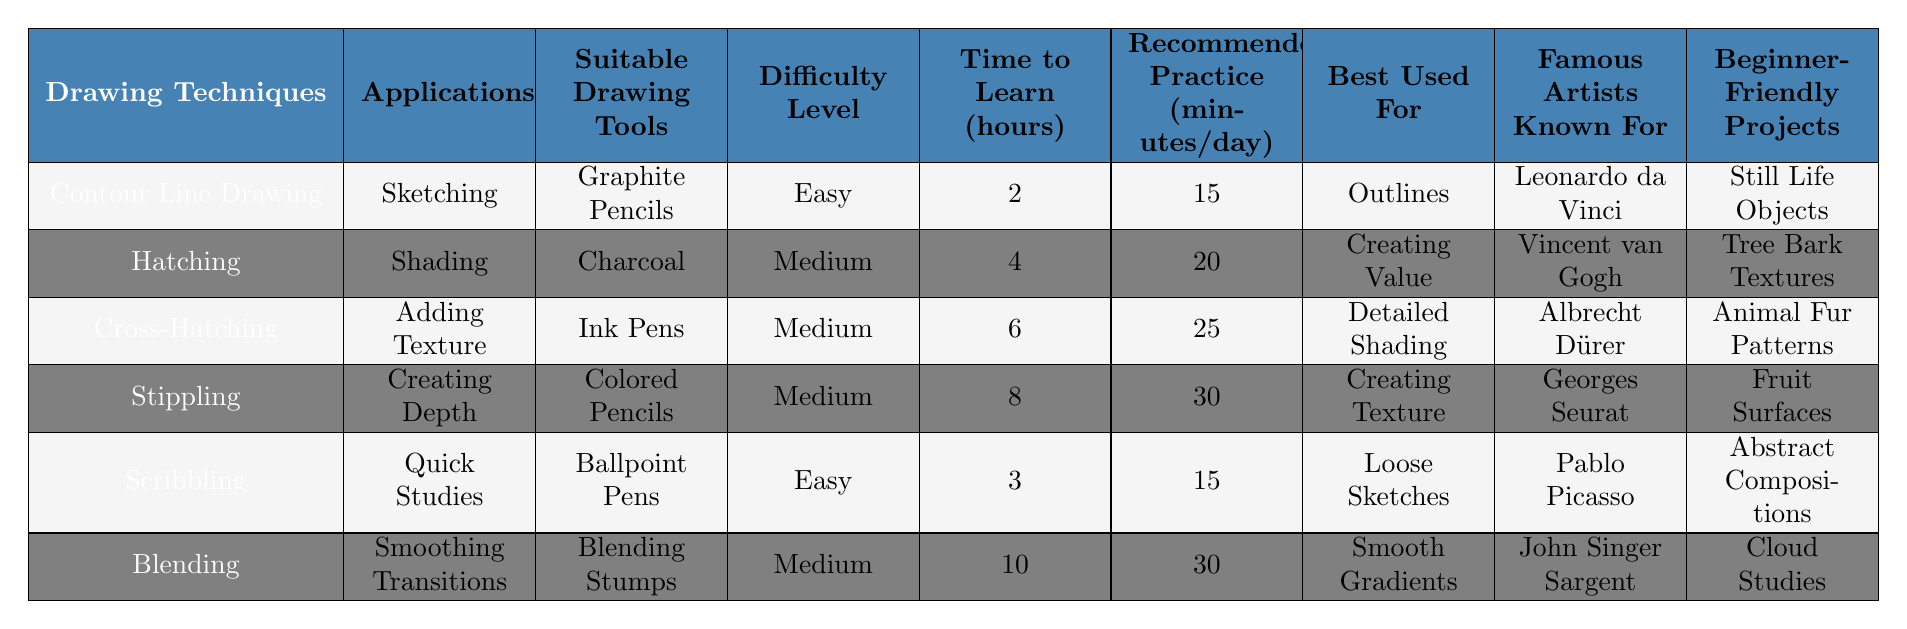What is the most difficult drawing technique to learn? The drawing technique with the highest difficulty level listed in the table is "Blending," which is categorized as "Medium," but it has the longest time to learn at 10 hours, indicating it might be more challenging in practice.
Answer: Blending Which drawing technique is best for adding texture? According to the table, "Cross-Hatching" is specifically listed as being used for "Adding Texture."
Answer: Cross-Hatching How many hours does it take to learn "Scribbling"? The table indicates that "Scribbling" takes 3 hours to learn.
Answer: 3 hours Are all drawing techniques suitable for beginners? No, not all techniques are suitable for beginners; "Hatching," "Cross-Hatching," "Stippling," and "Blending" are categorized as "Medium" in difficulty.
Answer: No What is the average time to learn all the drawing techniques? To find the average, sum the time to learn: (2 + 4 + 6 + 8 + 3 + 10) = 33 hours; then divide by the number of techniques, which is 6: 33 / 6 = 5.5 hours.
Answer: 5.5 hours Which techniques can be used with blending stumps? According to the table, "Blending" is the only technique that mentions "Blending Stumps" as its suitable drawing tool.
Answer: Blending Which famous artist is known for hatching? The table states that Vincent van Gogh is known for the drawing technique "Hatching."
Answer: Vincent van Gogh What is the recommended daily practice time for "Stippling"? The table indicates that "Stippling" has a recommended practice time of 30 minutes per day.
Answer: 30 minutes Which techniques are categorized as easy? The techniques categorized as "Easy" are "Contour Line Drawing" and "Scribbling."
Answer: Contour Line Drawing, Scribbling How many more minutes per day is recommended for practice for "Blending" compared to "Scribbling"? The recommended practice time for "Blending" is 30 minutes and for "Scribbling" is 15 minutes, so the difference is 30 - 15 = 15 minutes.
Answer: 15 minutes 